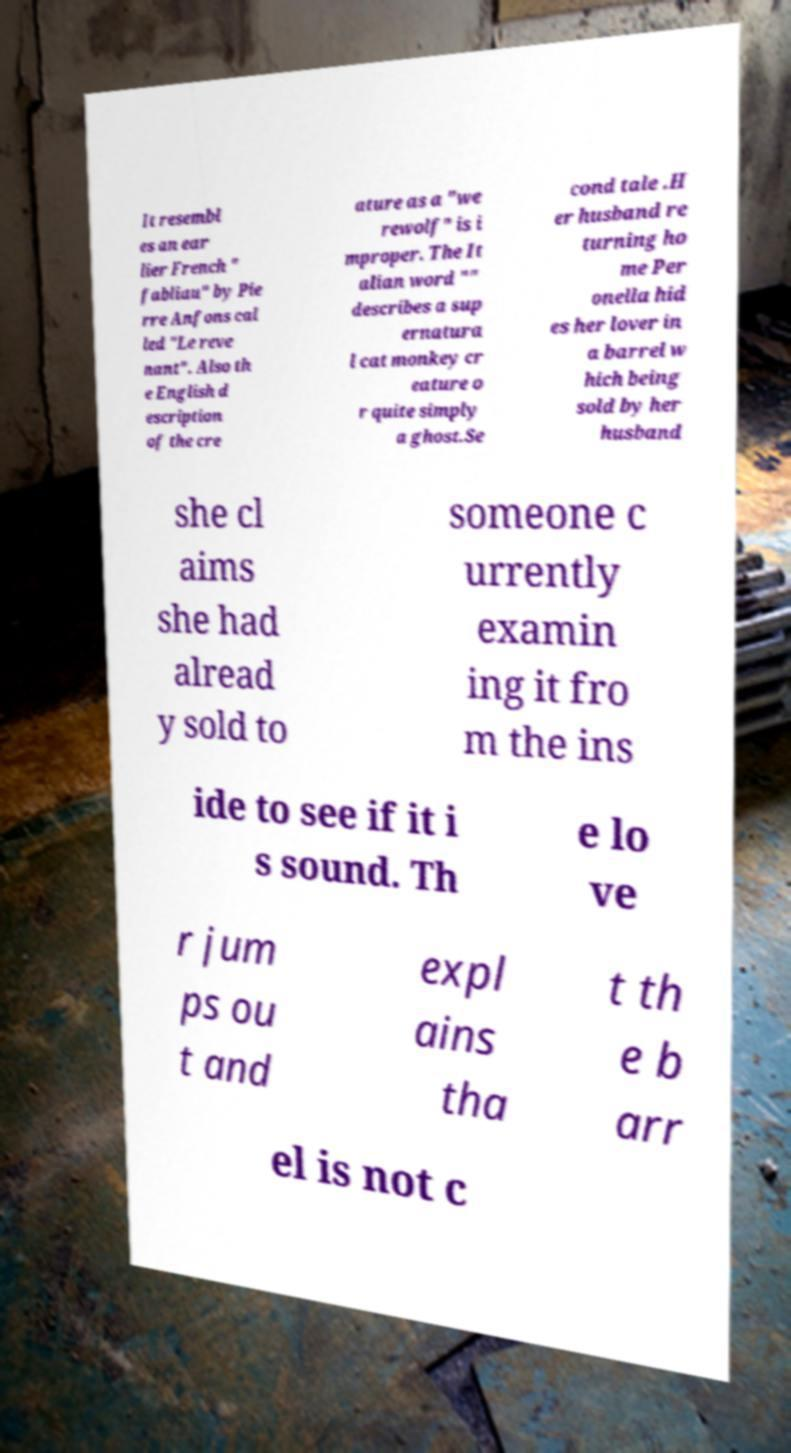Could you extract and type out the text from this image? It resembl es an ear lier French " fabliau" by Pie rre Anfons cal led "Le reve nant". Also th e English d escription of the cre ature as a "we rewolf" is i mproper. The It alian word "" describes a sup ernatura l cat monkey cr eature o r quite simply a ghost.Se cond tale .H er husband re turning ho me Per onella hid es her lover in a barrel w hich being sold by her husband she cl aims she had alread y sold to someone c urrently examin ing it fro m the ins ide to see if it i s sound. Th e lo ve r jum ps ou t and expl ains tha t th e b arr el is not c 